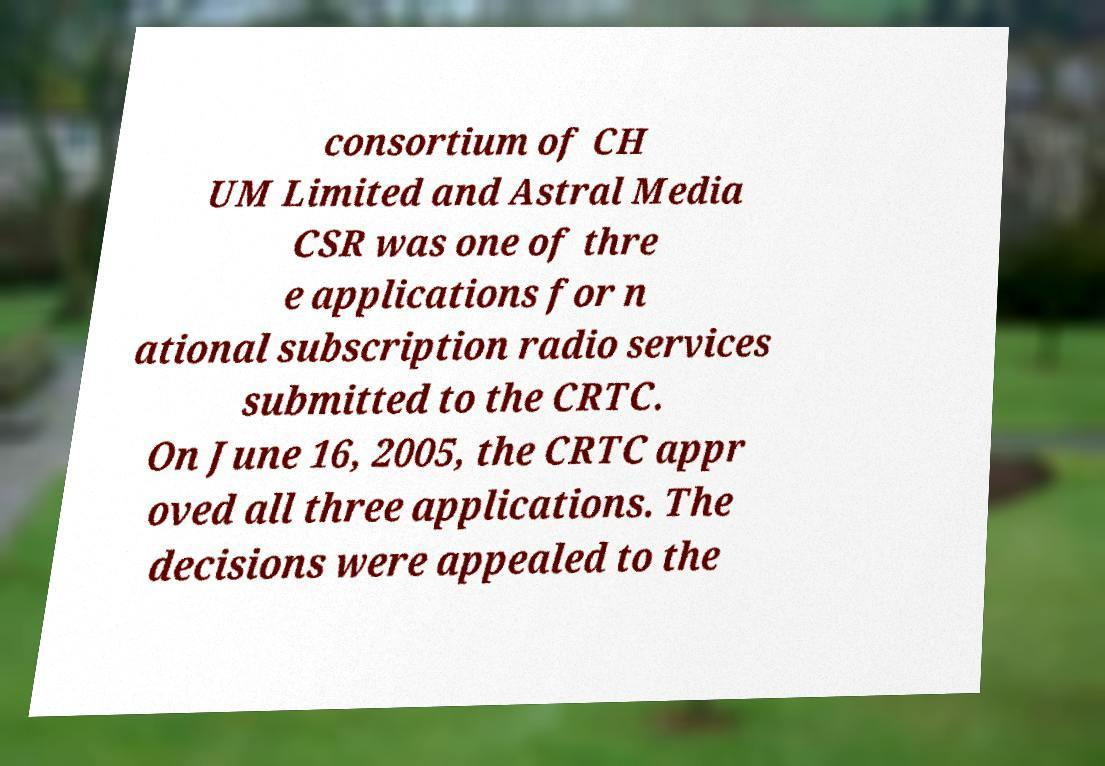Please identify and transcribe the text found in this image. consortium of CH UM Limited and Astral Media CSR was one of thre e applications for n ational subscription radio services submitted to the CRTC. On June 16, 2005, the CRTC appr oved all three applications. The decisions were appealed to the 